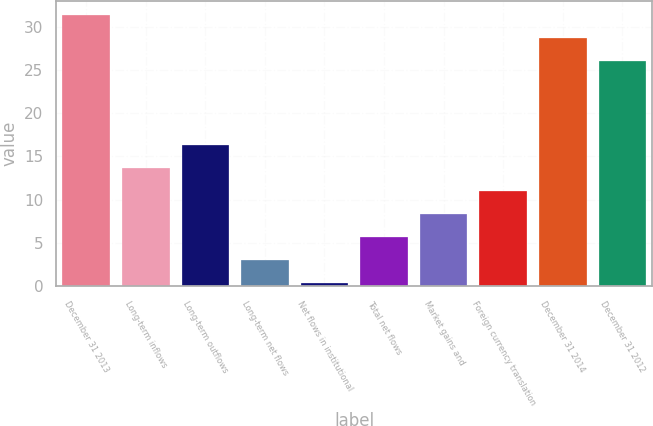Convert chart. <chart><loc_0><loc_0><loc_500><loc_500><bar_chart><fcel>December 31 2013<fcel>Long-term inflows<fcel>Long-term outflows<fcel>Long-term net flows<fcel>Net flows in institutional<fcel>Total net flows<fcel>Market gains and<fcel>Foreign currency translation<fcel>December 31 2014<fcel>December 31 2012<nl><fcel>31.44<fcel>13.7<fcel>16.38<fcel>2.98<fcel>0.3<fcel>5.66<fcel>8.34<fcel>11.02<fcel>28.76<fcel>26.08<nl></chart> 